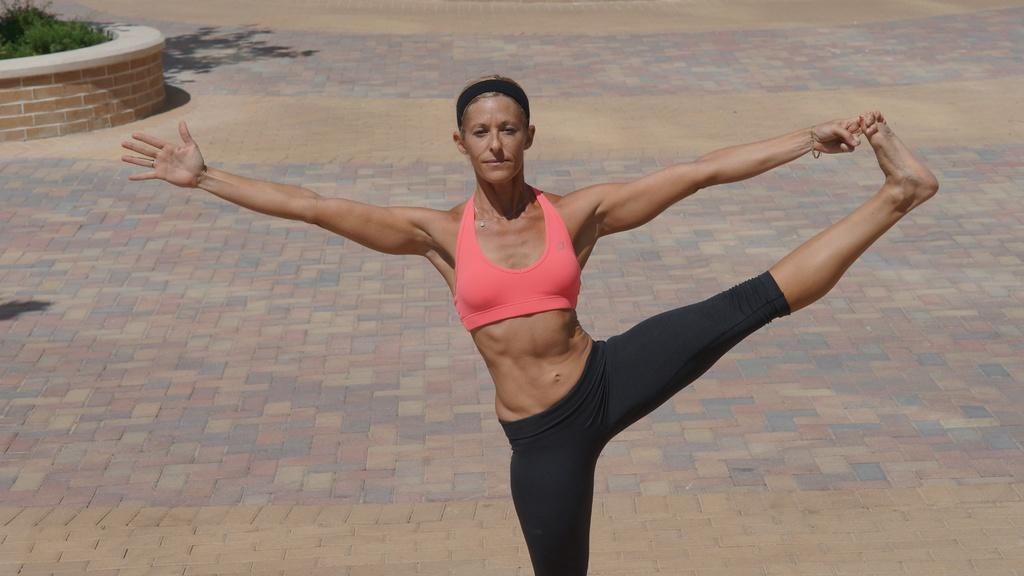What is the main subject of the image? There is a woman in the image. What is the woman doing in the image? The woman is stretching her body and doing aerobics. What type of clothing is the woman wearing? The woman is wearing a pink gym bra and black pants. What can be seen on the left side of the image? There are plants on the left side of the image. What type of toys can be seen in the image? There are no toys present in the image. Is the woman experiencing any trouble while doing aerobics in the image? The image does not provide any information about the woman experiencing trouble while doing aerobics. 